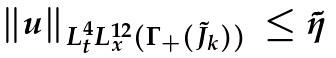<formula> <loc_0><loc_0><loc_500><loc_500>\begin{array} { l l } \| u \| _ { L _ { t } ^ { 4 } L _ { x } ^ { 1 2 } ( \Gamma _ { + } ( \tilde { J } _ { k } ) ) } & \leq \tilde { \eta } \end{array}</formula> 